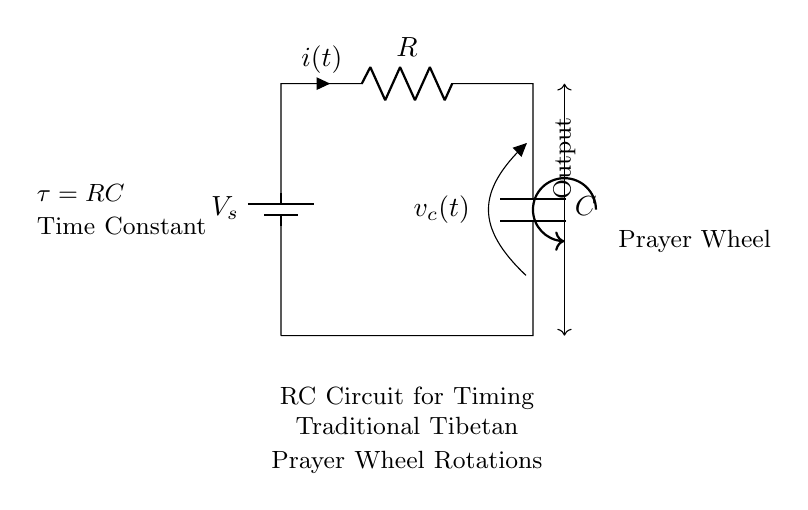What is the value of the resistor in the circuit? The resistor is indicated with the label R, which means its value can be denoted as R. The actual numerical value isn't specified in the diagram, but it refers to the resistance component.
Answer: R What does the capacitor store in this circuit? The capacitor is labeled as C, which means it stores electrical charge. In the context of this circuit, it stores energy that can be used to power the prayer wheel.
Answer: Electrical charge What is the function of the time constant in the circuit? The time constant tau, represented as τ = RC, describes how quickly the capacitor charges or discharges. It indicates the time taken for the voltage across the capacitor to reach approximately 63.2% of its final value after a step change in voltage.
Answer: τ = RC What is the output of the circuit? The output of the circuit is the voltage across the capacitor, as indicated by the labeling. It provides the necessary voltage to control the timing of the prayer wheel's rotations.
Answer: Voltage across C Why is this an RC circuit? This is an RC circuit because it contains both a resistor and a capacitor connected in series, which is the defining characteristic of such circuits. The presence of these components allows for charging and discharging behaviors typical in RC circuits.
Answer: Resistor and capacitor What happens to the prayer wheel when the voltage changes? When the voltage from the battery changes, it affects the charge time of the capacitor, which in turn influences the rotation speed of the prayer wheel. A higher voltage will charge the capacitor faster, altering the timing intervals for the wheel's rotations.
Answer: Rotation speed changes What role does the battery play in this circuit? The battery provides the source voltage (labeled as V_s) that powers the circuit, initiating the charging and discharging processes of the capacitor. It is essential for the functioning of the circuit and the operation of the prayer wheel.
Answer: Provides voltage 